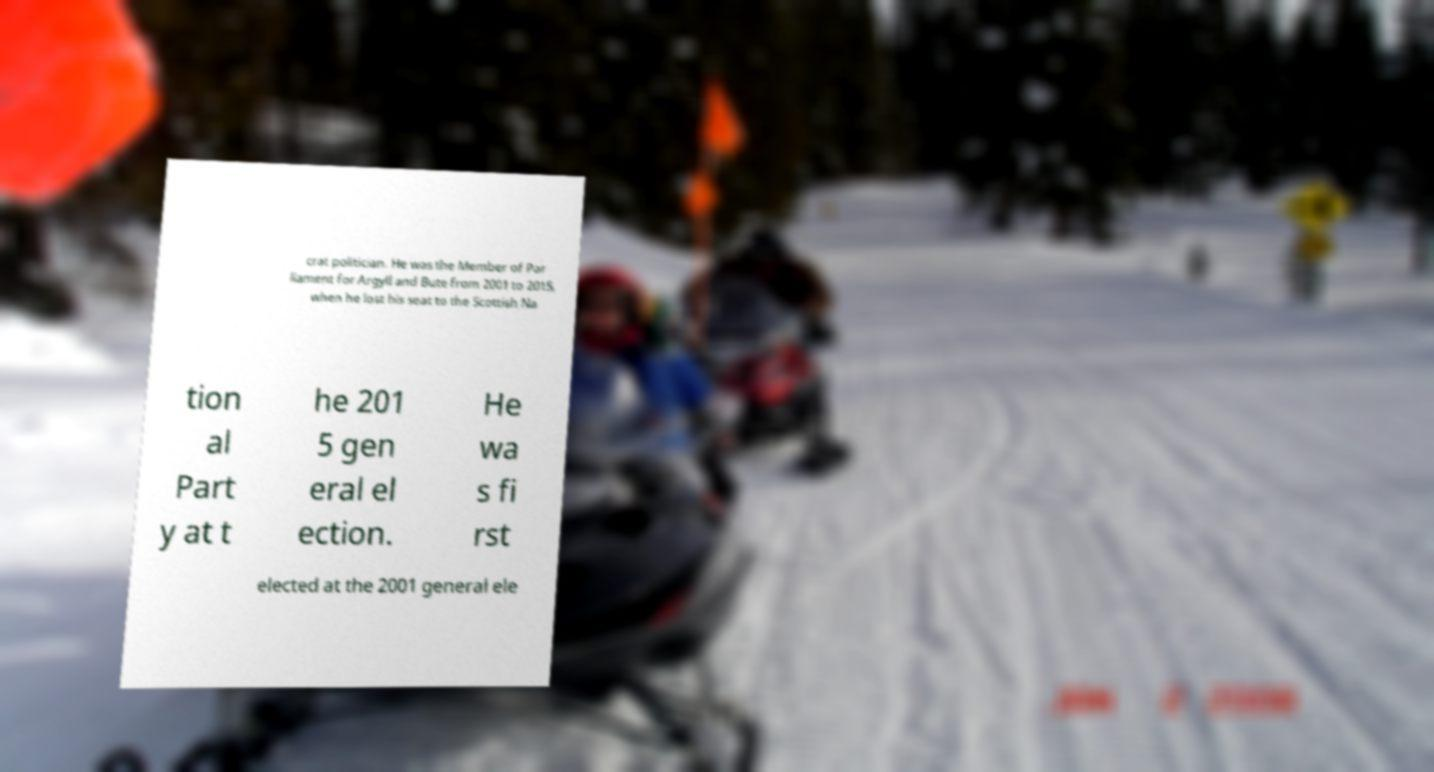What messages or text are displayed in this image? I need them in a readable, typed format. crat politician. He was the Member of Par liament for Argyll and Bute from 2001 to 2015, when he lost his seat to the Scottish Na tion al Part y at t he 201 5 gen eral el ection. He wa s fi rst elected at the 2001 general ele 